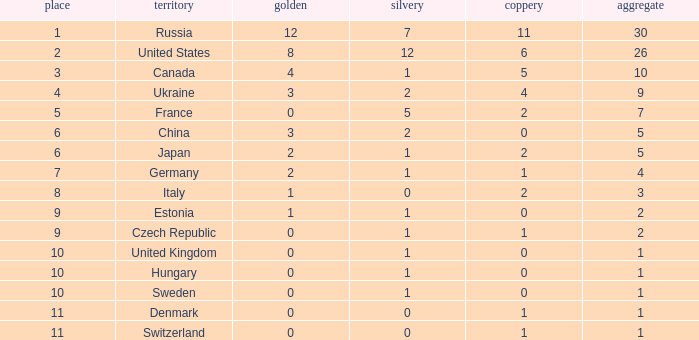What is the largest silver with Gold larger than 4, a Nation of united states, and a Total larger than 26? None. 